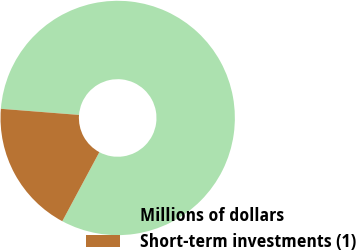<chart> <loc_0><loc_0><loc_500><loc_500><pie_chart><fcel>Millions of dollars<fcel>Short-term investments (1)<nl><fcel>81.59%<fcel>18.41%<nl></chart> 